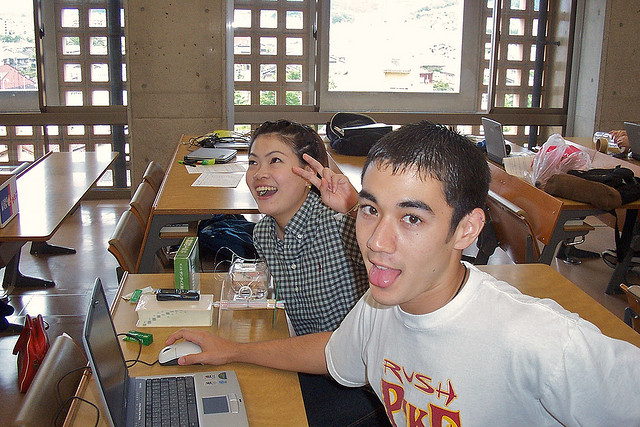Identify the text displayed in this image. RUSH RUSH 